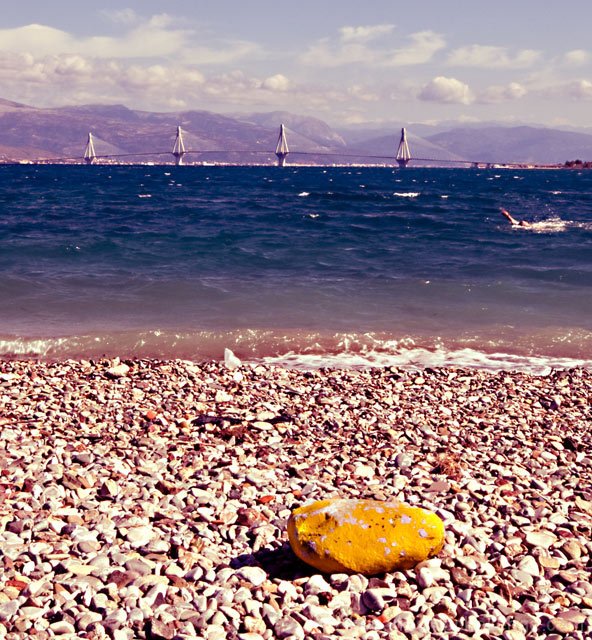Can you tell me about the artistic aspects of this image? Certainly, the image employs a strong use of contrasting colors, with the golden hue of the solitary rock standing out against the cooler tones of the pebbles, sea, and sky. The rule of thirds is subtly applied, with the horizon line positioned approximately one-third from the top of the frame. The sailboats provide a point of interest on this line, drawing the viewer's eye across the scene. The composition leads to a harmonious balance between elements of nature and human activity. Does the image convey any particular mood or atmosphere? The image exudes a sense of tranquility and solitude, emphasized by the vastness of the sea and the open sky. The presence of the sailboats hints at a quiet bustle in the distance, yet the beach itself lies untouched, save for the singular rock, which adds a note of contemplation or loneliness to the scene. 